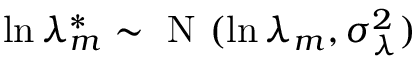Convert formula to latex. <formula><loc_0><loc_0><loc_500><loc_500>\ln \lambda _ { m } ^ { * } \sim N ( \ln \lambda _ { m } , \sigma _ { \lambda } ^ { 2 } )</formula> 